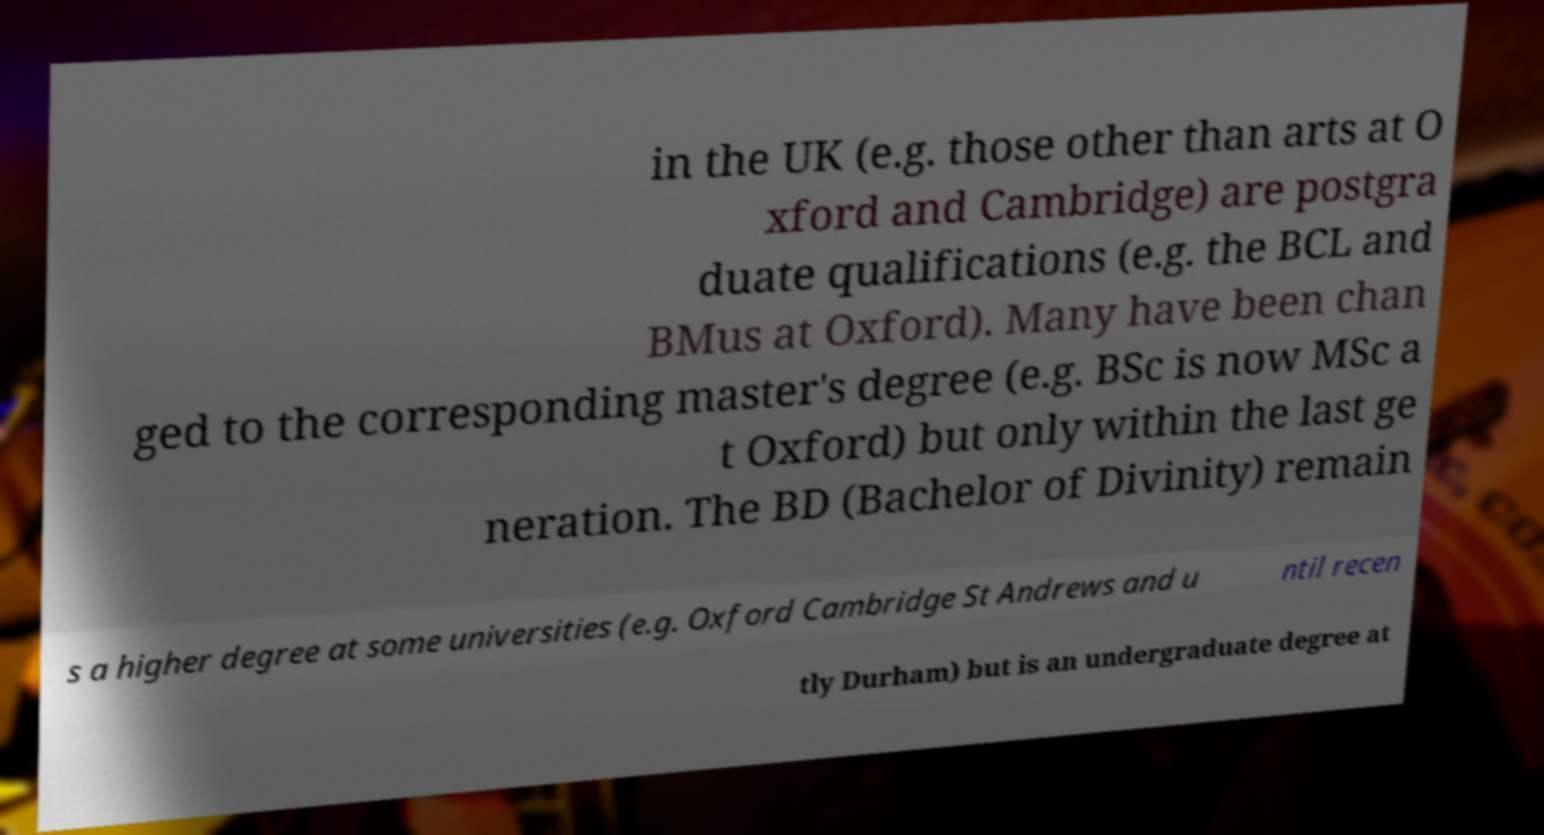Could you assist in decoding the text presented in this image and type it out clearly? in the UK (e.g. those other than arts at O xford and Cambridge) are postgra duate qualifications (e.g. the BCL and BMus at Oxford). Many have been chan ged to the corresponding master's degree (e.g. BSc is now MSc a t Oxford) but only within the last ge neration. The BD (Bachelor of Divinity) remain s a higher degree at some universities (e.g. Oxford Cambridge St Andrews and u ntil recen tly Durham) but is an undergraduate degree at 